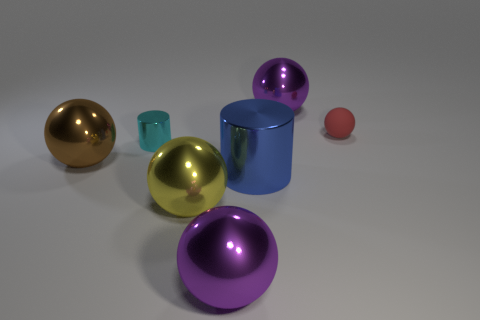Are there any other things that are the same material as the yellow ball?
Give a very brief answer. Yes. What is the material of the big sphere that is to the right of the ball that is in front of the yellow ball?
Keep it short and to the point. Metal. What is the color of the tiny metallic thing?
Give a very brief answer. Cyan. There is a big metallic object behind the small cylinder; are there any blue metallic things behind it?
Keep it short and to the point. No. What is the red ball made of?
Your response must be concise. Rubber. Are the small thing that is in front of the red matte ball and the large purple object in front of the blue metal cylinder made of the same material?
Your answer should be compact. Yes. Is there any other thing that has the same color as the small cylinder?
Your response must be concise. No. There is another rubber thing that is the same shape as the large yellow thing; what color is it?
Your response must be concise. Red. There is a thing that is both behind the large brown metallic sphere and left of the yellow object; what size is it?
Your answer should be very brief. Small. There is a large object that is left of the yellow object; is its shape the same as the tiny thing that is to the left of the yellow metallic thing?
Give a very brief answer. No. 